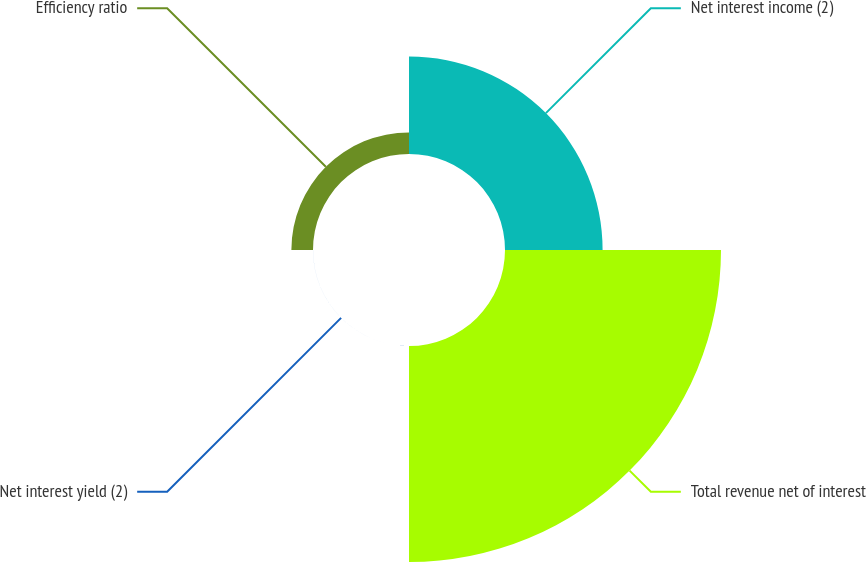<chart> <loc_0><loc_0><loc_500><loc_500><pie_chart><fcel>Net interest income (2)<fcel>Total revenue net of interest<fcel>Net interest yield (2)<fcel>Efficiency ratio<nl><fcel>29.11%<fcel>64.43%<fcel>0.01%<fcel>6.45%<nl></chart> 